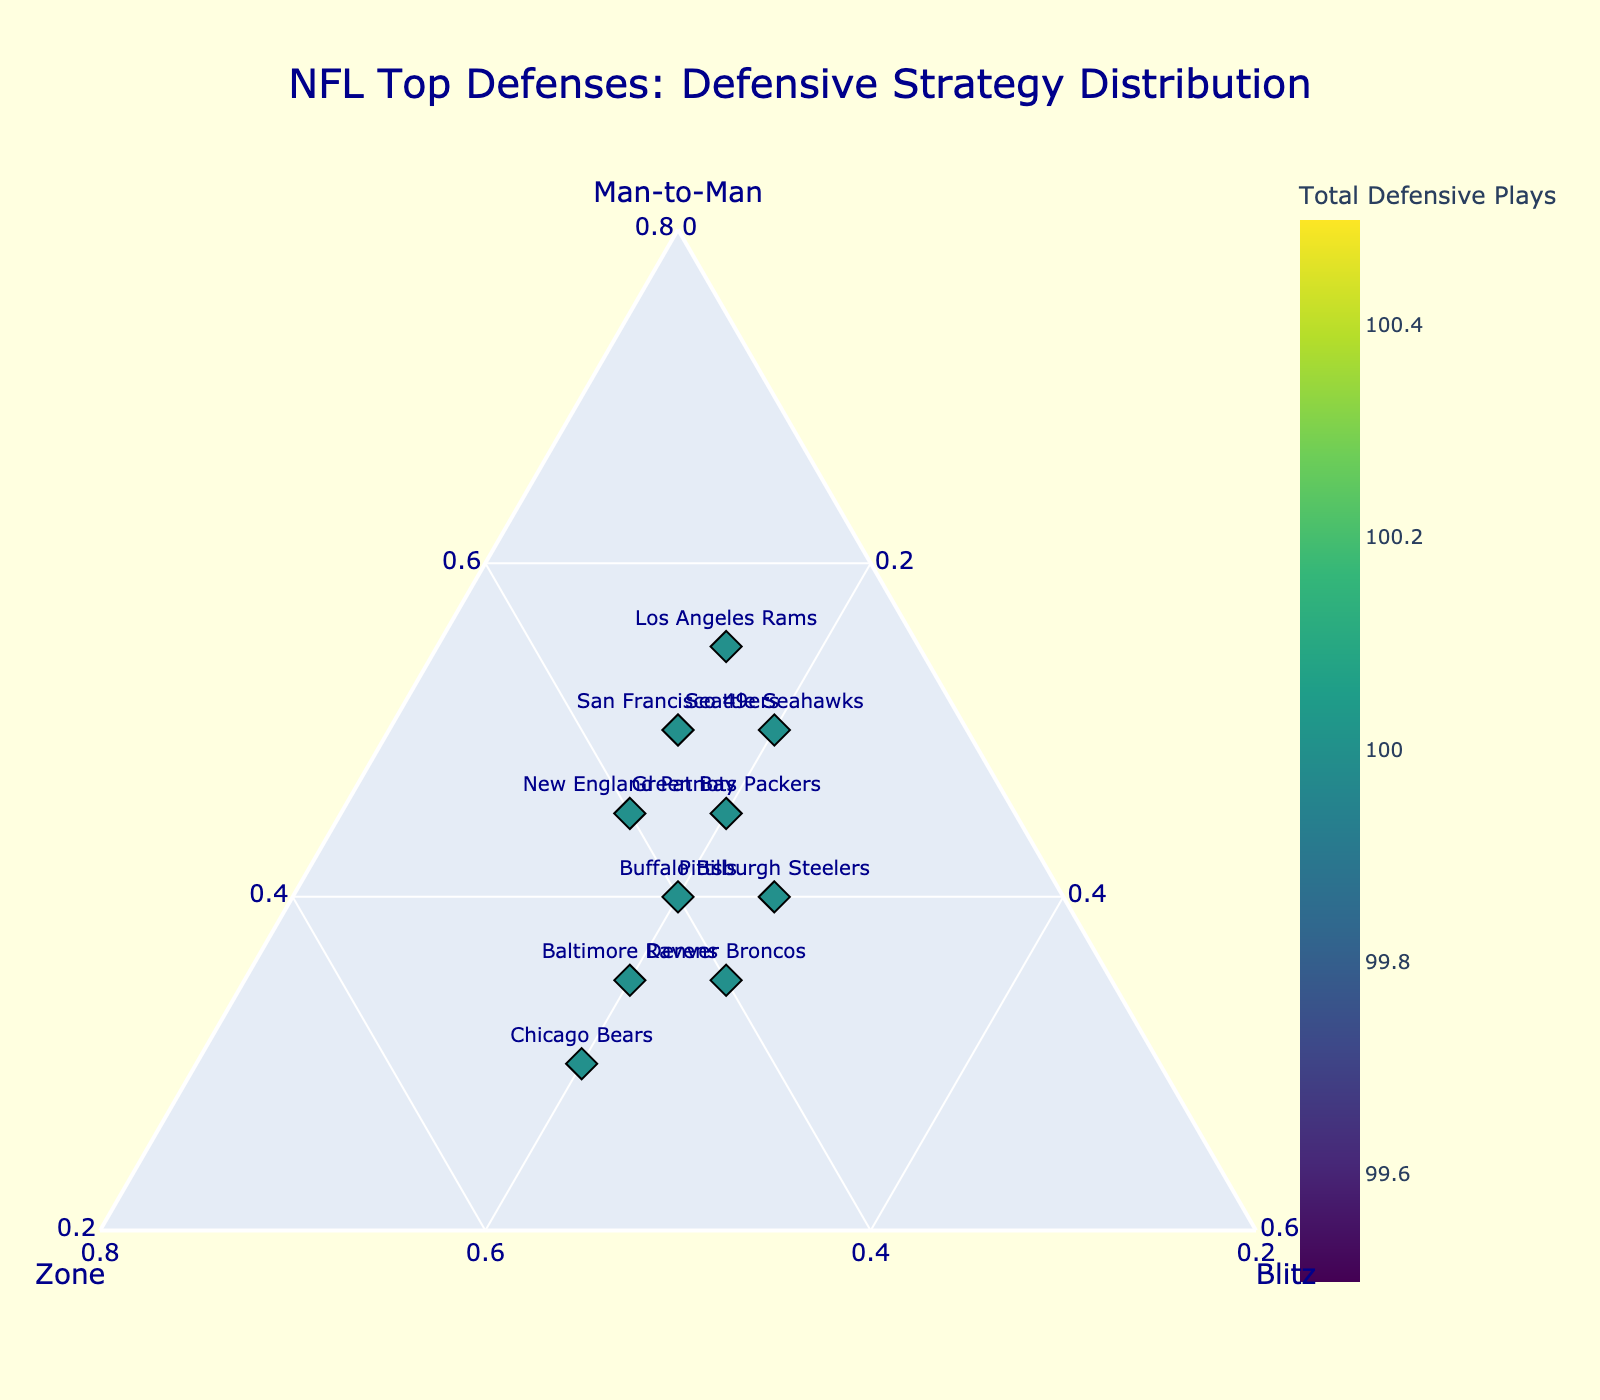Which team has the highest percentage of man-to-man strategy? Locate the team farthest towards the "Man-to-Man" axis. The Los Angeles Rams are on the outermost edge towards "Man-to-Man" with 55% normalized.
Answer: Los Angeles Rams What is the title of the figure? The title can be found centered at the top of the plot in larger text, highlighting the main focus. It reads "NFL Top Defenses: Defensive Strategy Distribution".
Answer: NFL Top Defenses: Defensive Strategy Distribution Which team employs the most balanced mix of man-to-man, zone, and blitz strategies? Balanced strategies can be identified near the center of the plot where no one strategy dominates. The Buffalo Bills have 40% man-to-man, 40% zone, and 20% blitz, placing them centrally.
Answer: Buffalo Bills Compare the distribution of defensive strategies between the New England Patriots and Chicago Bears. The Patriots use 45% man-to-man, 40% zone, and 15% blitz, while the Bears use 30% man-to-man, 50% zone, and 20% blitz. The Patriots rely more on man-to-man, whereas the Bears use zone more.
Answer: Patriots: more man-to-man; Bears: more zone Which team uses the blitz strategy the most? The team closest to the "Blitz" vertex has the highest percentage of blitz plays. The Pittsburgh Steelers, at 25%, are closest to the "Blitz" vertex.
Answer: Pittsburgh Steelers Which team has the smallest percentage of zone strategy? The team farthest from the "Zone" axis has the lowest zone percentage. The Los Angeles Rams are farthest with only 30% zone.
Answer: Los Angeles Rams What's the combined percentage of man-to-man and blitz strategies for the Denver Broncos? Add the percentages of man-to-man (35%) and blitz (25%) used by the Broncos. The calculation is 35% + 25% = 60%.
Answer: 60% Identify the team with exactly equal usage of man-to-man and zone strategies. Look for a team on the line between the "Man-to-Man" and "Zone" axes with equal distribution. The New England Patriots and the Buffalo Bills both use 40% each but the Patriots have other strategy included.
Answer: Buffalo Bills Which team appears closest to the "Zone" axis, ignoring the other two strategies? The team positioned nearest to the "Zone" axis without regard for "Man-to-Man" or "Blitz" is the Chicago Bears, using 50% zone.
Answer: Chicago Bears What is the range of man-to-man percentages among all teams? Identify the highest and lowest percentages of man-to-man strategy, which are 55% (Los Angeles Rams) and 30% (Chicago Bears), respectively. Range can be calculated as 55% - 30% = 25%.
Answer: 25% 